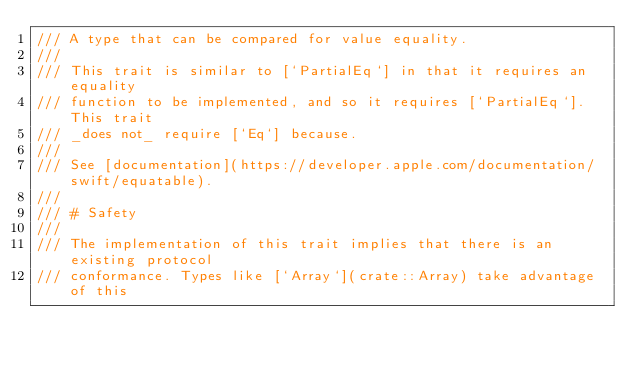Convert code to text. <code><loc_0><loc_0><loc_500><loc_500><_Rust_>/// A type that can be compared for value equality.
///
/// This trait is similar to [`PartialEq`] in that it requires an equality
/// function to be implemented, and so it requires [`PartialEq`]. This trait
/// _does not_ require [`Eq`] because.
///
/// See [documentation](https://developer.apple.com/documentation/swift/equatable).
///
/// # Safety
///
/// The implementation of this trait implies that there is an existing protocol
/// conformance. Types like [`Array`](crate::Array) take advantage of this</code> 